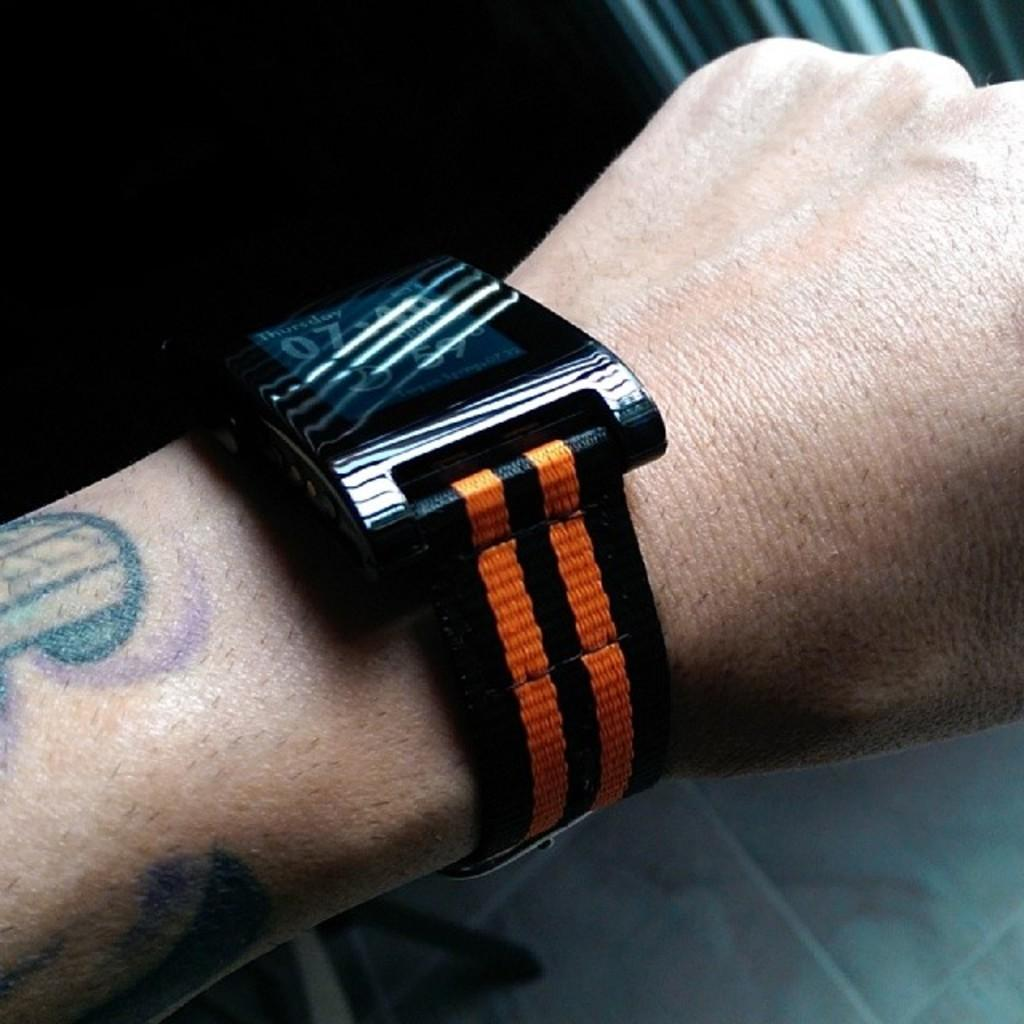<image>
Create a compact narrative representing the image presented. A wrist watch has a digital display with Thursday and 59 degrees. 